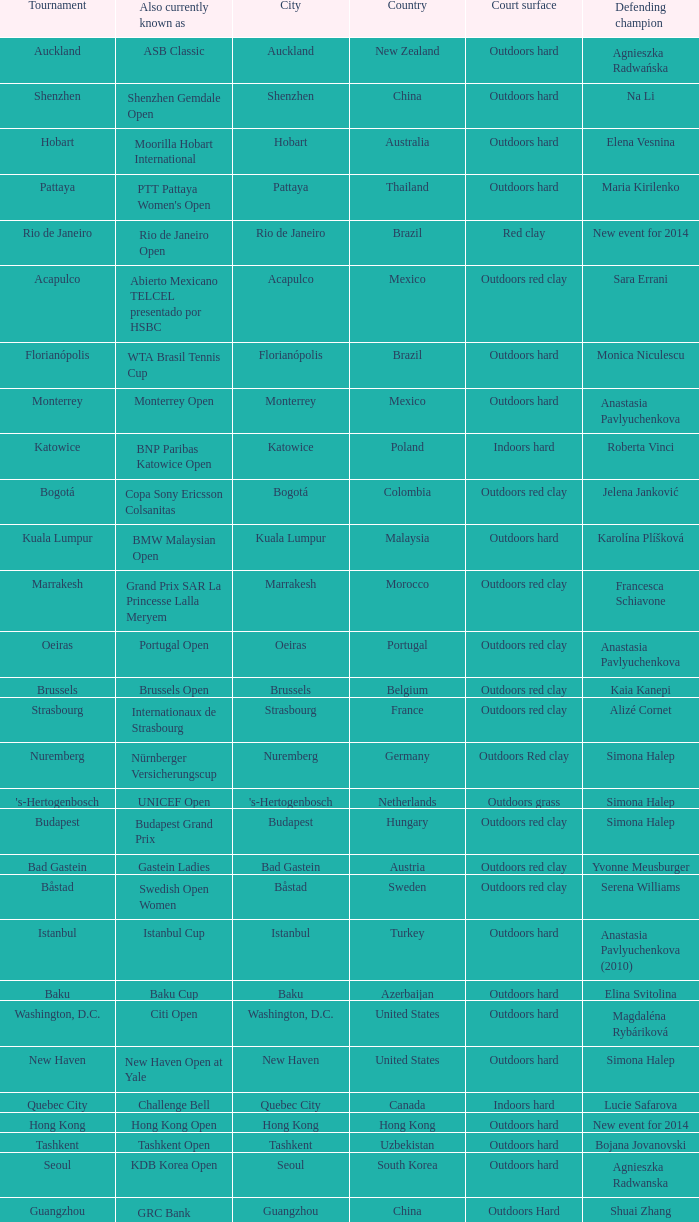What championship is in katowice? Katowice. 